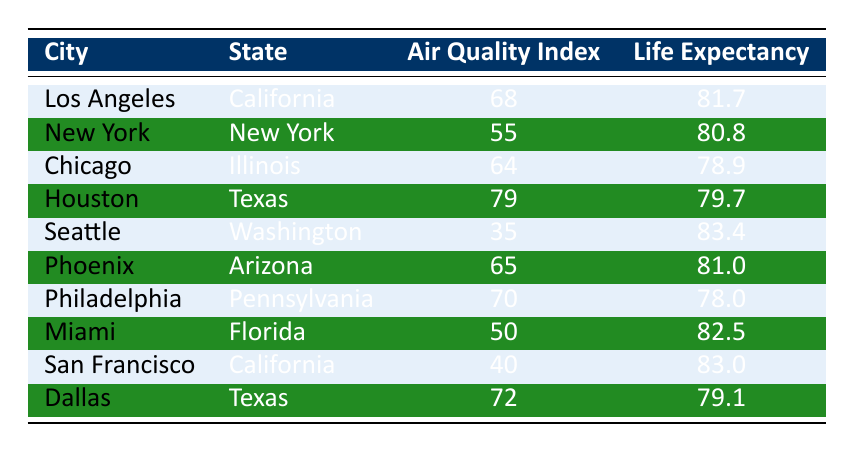What is the life expectancy in Los Angeles? The table shows that the life expectancy in Los Angeles is listed as 81.7 years.
Answer: 81.7 What city has the highest average air quality index? By examining the average air quality index values in the table, Houston has the highest index at 79.
Answer: Houston Is the air quality index for Miami lower than that of New York? The air quality index for Miami is 50, while for New York it is 55. Since 50 is less than 55, Miami's air quality index is indeed lower.
Answer: Yes What is the difference in life expectancy between Seattle and Chicago? The life expectancy in Seattle is 83.4, and in Chicago it is 78.9. The difference is calculated as 83.4 - 78.9 = 4.5 years.
Answer: 4.5 Which city has a life expectancy between 80 and 82 years? By inspecting the life expectancy column, the cities with life expectancy between 80 and 82 years are Los Angeles (81.7) and Phoenix (81.0).
Answer: Los Angeles and Phoenix What is the average life expectancy of all the cities listed? Adding the life expectancies of all cities: 81.7 + 80.8 + 78.9 + 79.7 + 83.4 + 81.0 + 78.0 + 82.5 + 83.0 + 79.1 =  818.1 years. To find the average, divide 818.1 by the number of cities (10), giving an average life expectancy of 81.81 years.
Answer: 81.81 Is it true that all cities with an air quality index above 70 have a life expectancy above 80? Checking the table, both Houston (AQI 79, life expectancy 79.7) and Dallas (AQI 72, life expectancy 79.1) have an air quality index above 70 but have life expectancies below 80. Therefore, the statement is not true.
Answer: No How does the average air quality index compare for cities in California versus Texas? The average air quality index for California (Los Angeles 68 and San Francisco 40) is (68 + 40) / 2 = 54. The average for Texas (Houston 79 and Dallas 72) is (79 + 72) / 2 = 75. Comparing these averages, Texas has a higher average air quality index than California.
Answer: Texas has a higher average air quality index Which state has the lowest average life expectancy among the listed cities? Calculating life expectancy per state shows that the lowest life expectancy is found in Illinois (Chicago) at 78.9, which is lower than the others.
Answer: Illinois 